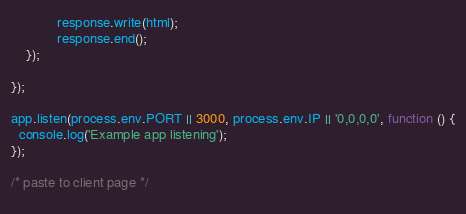Convert code to text. <code><loc_0><loc_0><loc_500><loc_500><_JavaScript_>            response.write(html);  
            response.end();  
    });
    
});
 
app.listen(process.env.PORT || 3000, process.env.IP || '0,0,0,0', function () {
  console.log('Example app listening');
});
 
/* paste to client page */
 </code> 